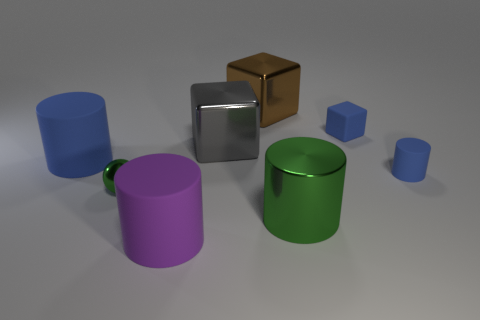Can you tell me about the objects that have a metallic texture in the image? Two objects in the image exhibit a metallic texture: one is a silver cube and the other is a gold cube. These cubes reflect light differently than the other matte-finished objects, giving them a distinctive shiny appearance. 